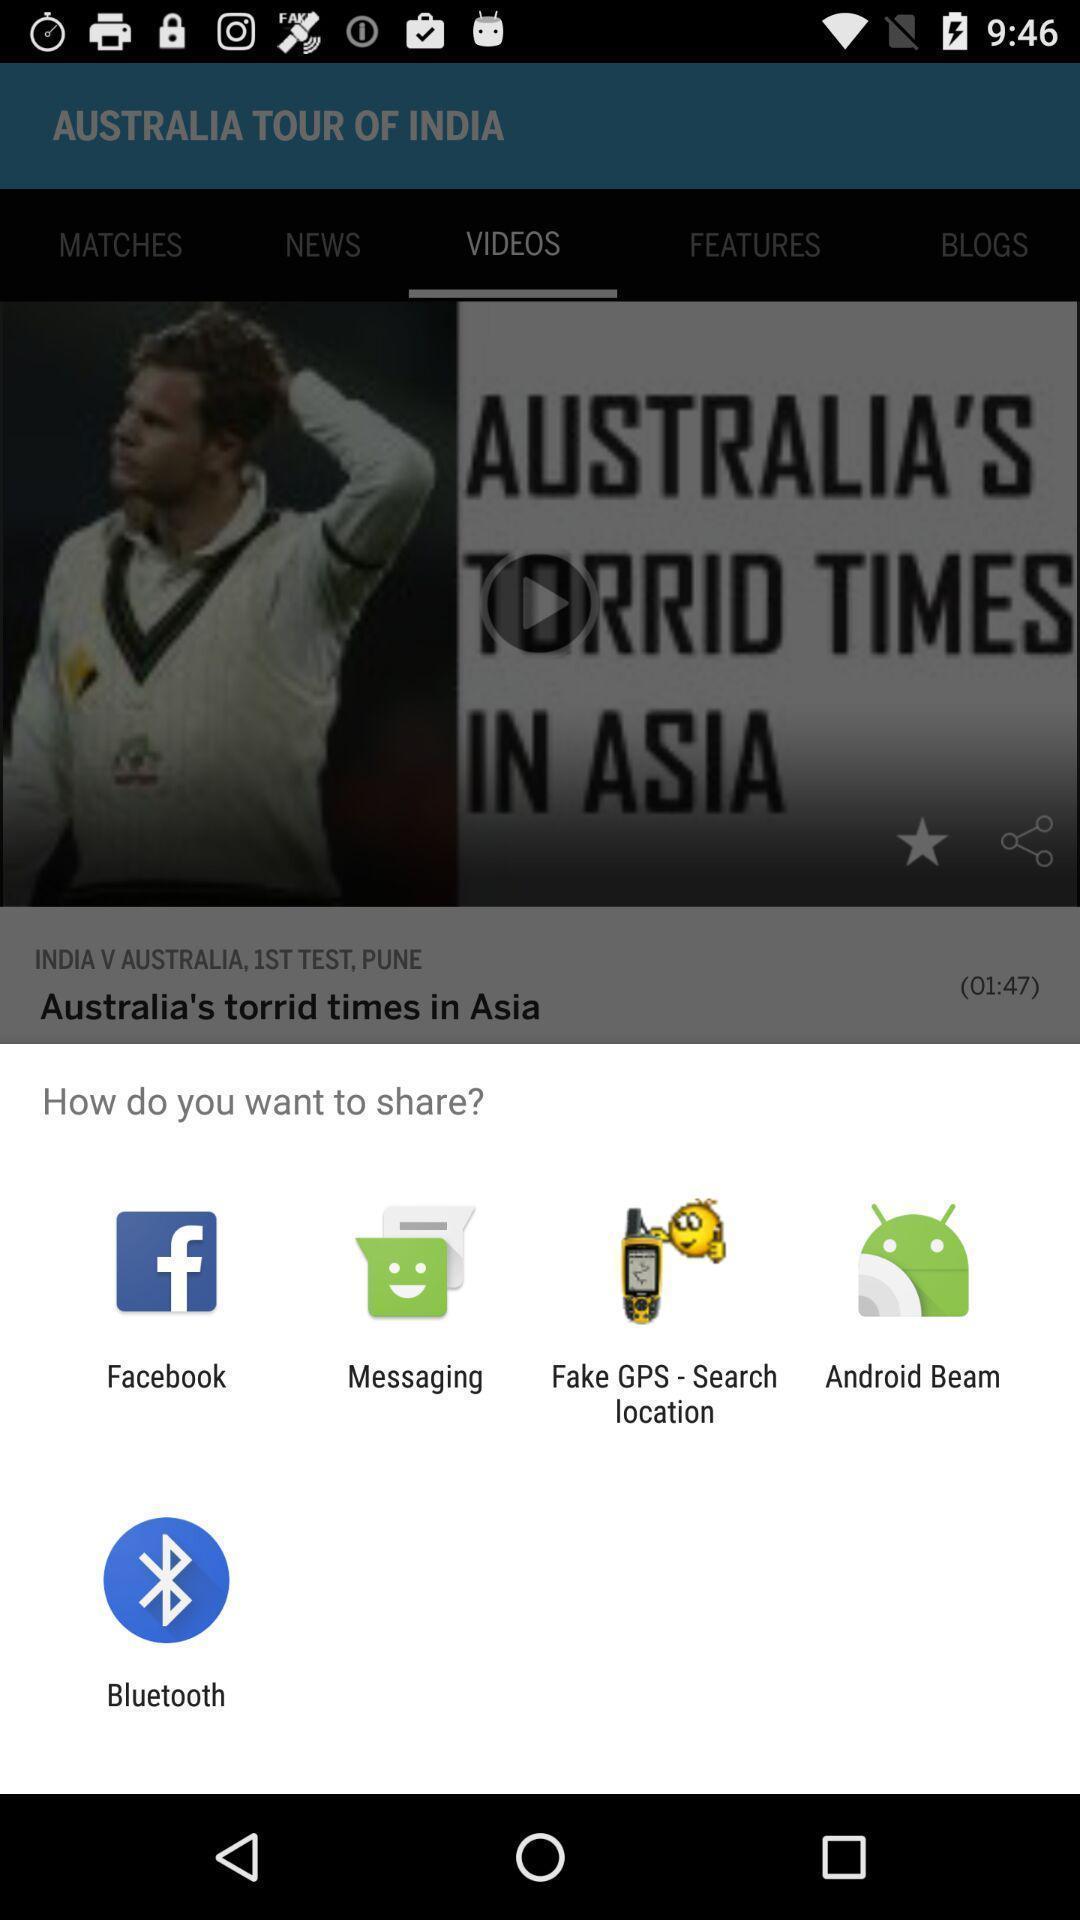Please provide a description for this image. Popup showing different apps to share. 